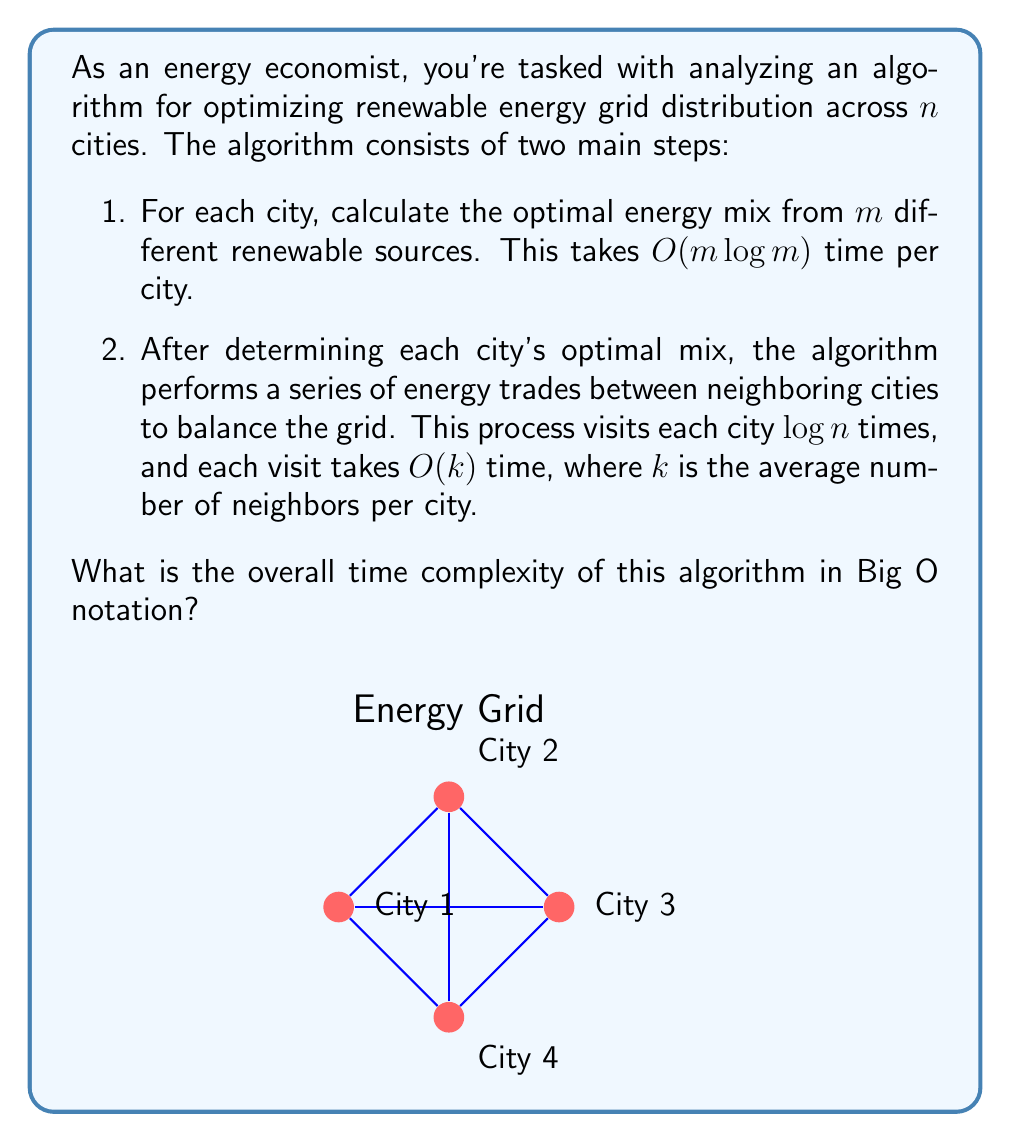Give your solution to this math problem. Let's break down the problem and analyze each step:

1. Calculating optimal energy mix for each city:
   - This step is performed for each of the $n$ cities.
   - For each city, the time complexity is $O(m \log m)$.
   - Total time for this step: $O(n \cdot m \log m)$

2. Balancing the grid through energy trades:
   - The process visits each city $\log n$ times.
   - Each visit takes $O(k)$ time.
   - This is done for all $n$ cities.
   - Total time for this step: $O(n \cdot \log n \cdot k)$

To get the overall time complexity, we add these two steps together:

$$O(n \cdot m \log m + n \cdot \log n \cdot k)$$

We can factor out $n$:

$$O(n \cdot (m \log m + \log n \cdot k))$$

In Big O notation, we're interested in the worst-case scenario and the dominant terms as the input size grows. Here, $n$ represents the number of cities, which is likely to be the largest growing factor. The number of renewable sources $m$ and the average number of neighbors $k$ are likely to be relatively constant or grow much slower than $n$.

Therefore, the dominant term will be $n \log n$, as it grows faster than $n$ alone when $n$ becomes very large.

Thus, we can simplify the time complexity to:

$$O(n \log n)$$

This represents the upper bound of the algorithm's running time as the number of cities increases.
Answer: $O(n \log n)$ 